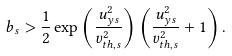<formula> <loc_0><loc_0><loc_500><loc_500>b _ { s } > \frac { 1 } { 2 } \exp \left ( \frac { u _ { y s } ^ { 2 } } { v _ { t h , s } ^ { 2 } } \right ) \left ( \frac { u _ { y s } ^ { 2 } } { v _ { t h , s } ^ { 2 } } + 1 \right ) .</formula> 